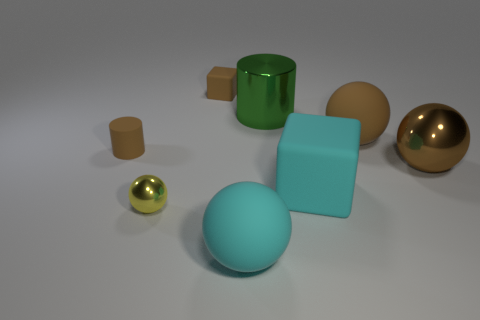The metal object that is the same color as the small matte block is what shape?
Keep it short and to the point. Sphere. Do the tiny cylinder and the big metal ball have the same color?
Your answer should be very brief. Yes. The metallic ball that is the same color as the tiny matte cylinder is what size?
Make the answer very short. Large. Is there a big cyan thing that has the same material as the brown cube?
Your response must be concise. Yes. What color is the sphere on the left side of the big cyan object in front of the cyan object behind the small metal sphere?
Offer a terse response. Yellow. How many brown objects are cubes or large shiny cylinders?
Provide a succinct answer. 1. What number of cyan objects are the same shape as the small yellow object?
Keep it short and to the point. 1. The yellow object that is the same size as the brown cylinder is what shape?
Give a very brief answer. Sphere. Are there any yellow shiny spheres on the right side of the cyan cube?
Ensure brevity in your answer.  No. There is a yellow object on the left side of the large green metal cylinder; is there a yellow shiny ball on the left side of it?
Provide a succinct answer. No. 